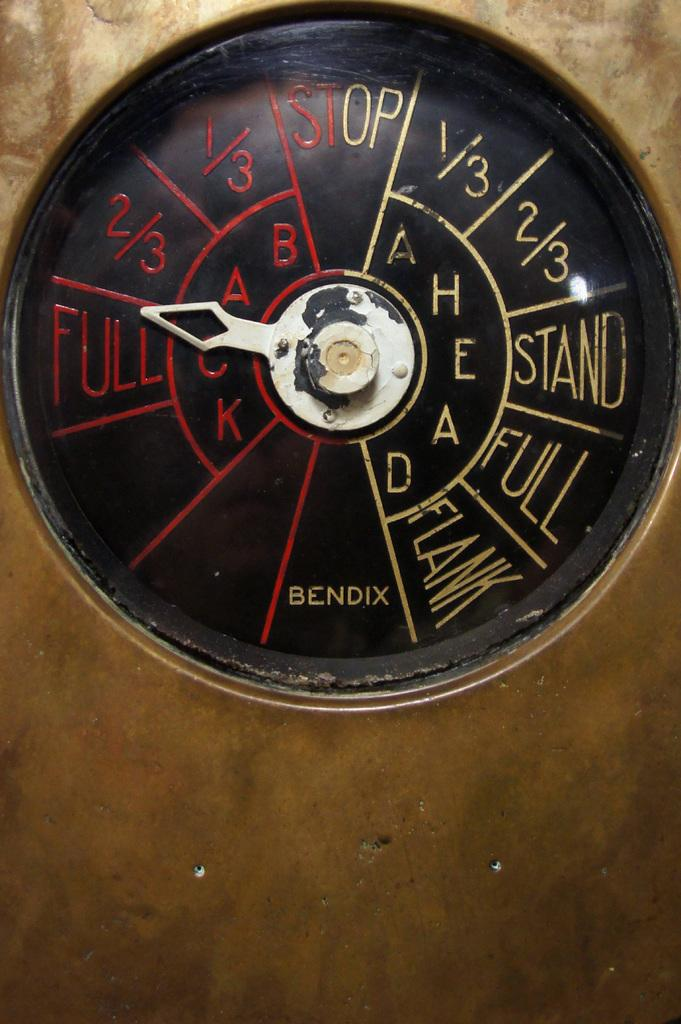<image>
Create a compact narrative representing the image presented. A gauge with an arrow points to Full on the left side. 